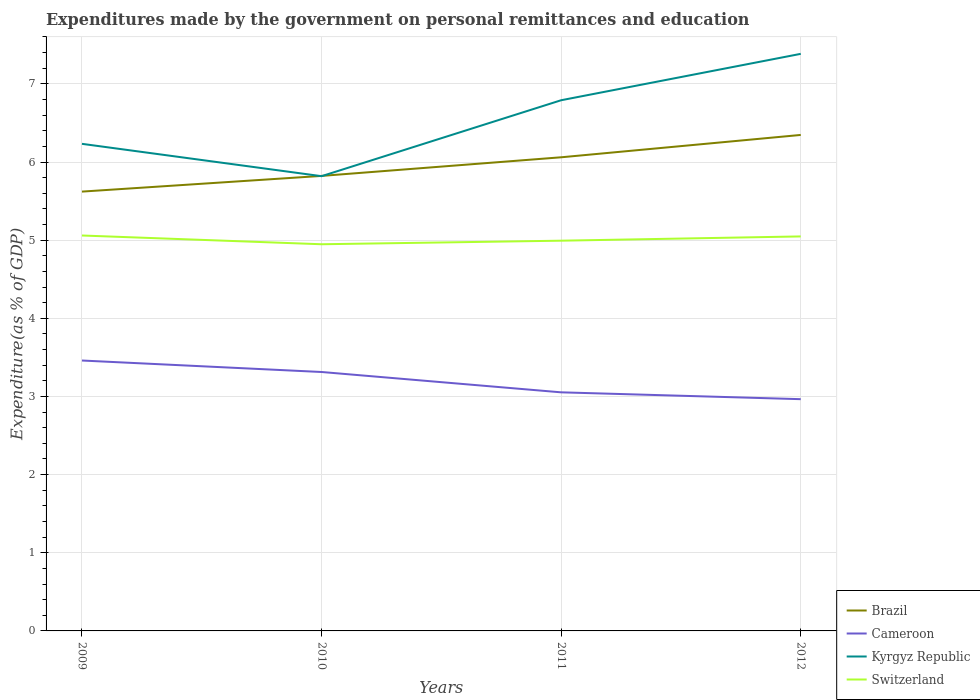Does the line corresponding to Switzerland intersect with the line corresponding to Brazil?
Provide a short and direct response. No. Is the number of lines equal to the number of legend labels?
Your answer should be very brief. Yes. Across all years, what is the maximum expenditures made by the government on personal remittances and education in Kyrgyz Republic?
Provide a succinct answer. 5.82. In which year was the expenditures made by the government on personal remittances and education in Cameroon maximum?
Offer a very short reply. 2012. What is the total expenditures made by the government on personal remittances and education in Cameroon in the graph?
Keep it short and to the point. 0.35. What is the difference between the highest and the second highest expenditures made by the government on personal remittances and education in Switzerland?
Provide a succinct answer. 0.11. What is the difference between the highest and the lowest expenditures made by the government on personal remittances and education in Switzerland?
Your answer should be compact. 2. Is the expenditures made by the government on personal remittances and education in Kyrgyz Republic strictly greater than the expenditures made by the government on personal remittances and education in Cameroon over the years?
Keep it short and to the point. No. How many lines are there?
Your answer should be very brief. 4. How many years are there in the graph?
Ensure brevity in your answer.  4. What is the difference between two consecutive major ticks on the Y-axis?
Your answer should be compact. 1. Does the graph contain grids?
Keep it short and to the point. Yes. What is the title of the graph?
Offer a very short reply. Expenditures made by the government on personal remittances and education. What is the label or title of the X-axis?
Your answer should be compact. Years. What is the label or title of the Y-axis?
Ensure brevity in your answer.  Expenditure(as % of GDP). What is the Expenditure(as % of GDP) of Brazil in 2009?
Make the answer very short. 5.62. What is the Expenditure(as % of GDP) in Cameroon in 2009?
Make the answer very short. 3.46. What is the Expenditure(as % of GDP) of Kyrgyz Republic in 2009?
Your response must be concise. 6.23. What is the Expenditure(as % of GDP) in Switzerland in 2009?
Keep it short and to the point. 5.06. What is the Expenditure(as % of GDP) in Brazil in 2010?
Give a very brief answer. 5.82. What is the Expenditure(as % of GDP) of Cameroon in 2010?
Provide a short and direct response. 3.31. What is the Expenditure(as % of GDP) of Kyrgyz Republic in 2010?
Keep it short and to the point. 5.82. What is the Expenditure(as % of GDP) of Switzerland in 2010?
Ensure brevity in your answer.  4.95. What is the Expenditure(as % of GDP) of Brazil in 2011?
Your response must be concise. 6.06. What is the Expenditure(as % of GDP) in Cameroon in 2011?
Your response must be concise. 3.05. What is the Expenditure(as % of GDP) of Kyrgyz Republic in 2011?
Give a very brief answer. 6.79. What is the Expenditure(as % of GDP) in Switzerland in 2011?
Your answer should be compact. 4.99. What is the Expenditure(as % of GDP) of Brazil in 2012?
Offer a very short reply. 6.35. What is the Expenditure(as % of GDP) in Cameroon in 2012?
Provide a short and direct response. 2.97. What is the Expenditure(as % of GDP) in Kyrgyz Republic in 2012?
Provide a succinct answer. 7.38. What is the Expenditure(as % of GDP) of Switzerland in 2012?
Make the answer very short. 5.05. Across all years, what is the maximum Expenditure(as % of GDP) of Brazil?
Provide a short and direct response. 6.35. Across all years, what is the maximum Expenditure(as % of GDP) of Cameroon?
Offer a very short reply. 3.46. Across all years, what is the maximum Expenditure(as % of GDP) in Kyrgyz Republic?
Provide a succinct answer. 7.38. Across all years, what is the maximum Expenditure(as % of GDP) of Switzerland?
Keep it short and to the point. 5.06. Across all years, what is the minimum Expenditure(as % of GDP) in Brazil?
Your answer should be very brief. 5.62. Across all years, what is the minimum Expenditure(as % of GDP) of Cameroon?
Your response must be concise. 2.97. Across all years, what is the minimum Expenditure(as % of GDP) of Kyrgyz Republic?
Make the answer very short. 5.82. Across all years, what is the minimum Expenditure(as % of GDP) in Switzerland?
Provide a short and direct response. 4.95. What is the total Expenditure(as % of GDP) of Brazil in the graph?
Your answer should be very brief. 23.85. What is the total Expenditure(as % of GDP) of Cameroon in the graph?
Your response must be concise. 12.79. What is the total Expenditure(as % of GDP) of Kyrgyz Republic in the graph?
Offer a very short reply. 26.23. What is the total Expenditure(as % of GDP) of Switzerland in the graph?
Your response must be concise. 20.05. What is the difference between the Expenditure(as % of GDP) in Brazil in 2009 and that in 2010?
Ensure brevity in your answer.  -0.2. What is the difference between the Expenditure(as % of GDP) in Cameroon in 2009 and that in 2010?
Give a very brief answer. 0.15. What is the difference between the Expenditure(as % of GDP) in Kyrgyz Republic in 2009 and that in 2010?
Offer a very short reply. 0.41. What is the difference between the Expenditure(as % of GDP) in Switzerland in 2009 and that in 2010?
Keep it short and to the point. 0.11. What is the difference between the Expenditure(as % of GDP) in Brazil in 2009 and that in 2011?
Provide a succinct answer. -0.44. What is the difference between the Expenditure(as % of GDP) of Cameroon in 2009 and that in 2011?
Ensure brevity in your answer.  0.41. What is the difference between the Expenditure(as % of GDP) in Kyrgyz Republic in 2009 and that in 2011?
Offer a very short reply. -0.56. What is the difference between the Expenditure(as % of GDP) of Switzerland in 2009 and that in 2011?
Keep it short and to the point. 0.07. What is the difference between the Expenditure(as % of GDP) of Brazil in 2009 and that in 2012?
Your answer should be compact. -0.73. What is the difference between the Expenditure(as % of GDP) of Cameroon in 2009 and that in 2012?
Your answer should be compact. 0.49. What is the difference between the Expenditure(as % of GDP) of Kyrgyz Republic in 2009 and that in 2012?
Your response must be concise. -1.15. What is the difference between the Expenditure(as % of GDP) in Switzerland in 2009 and that in 2012?
Your response must be concise. 0.01. What is the difference between the Expenditure(as % of GDP) in Brazil in 2010 and that in 2011?
Give a very brief answer. -0.24. What is the difference between the Expenditure(as % of GDP) of Cameroon in 2010 and that in 2011?
Offer a very short reply. 0.26. What is the difference between the Expenditure(as % of GDP) in Kyrgyz Republic in 2010 and that in 2011?
Your answer should be compact. -0.97. What is the difference between the Expenditure(as % of GDP) in Switzerland in 2010 and that in 2011?
Offer a terse response. -0.05. What is the difference between the Expenditure(as % of GDP) of Brazil in 2010 and that in 2012?
Provide a short and direct response. -0.52. What is the difference between the Expenditure(as % of GDP) of Cameroon in 2010 and that in 2012?
Your response must be concise. 0.35. What is the difference between the Expenditure(as % of GDP) of Kyrgyz Republic in 2010 and that in 2012?
Your answer should be compact. -1.57. What is the difference between the Expenditure(as % of GDP) of Switzerland in 2010 and that in 2012?
Your response must be concise. -0.1. What is the difference between the Expenditure(as % of GDP) in Brazil in 2011 and that in 2012?
Your answer should be very brief. -0.29. What is the difference between the Expenditure(as % of GDP) of Cameroon in 2011 and that in 2012?
Your answer should be very brief. 0.09. What is the difference between the Expenditure(as % of GDP) in Kyrgyz Republic in 2011 and that in 2012?
Your answer should be very brief. -0.59. What is the difference between the Expenditure(as % of GDP) of Switzerland in 2011 and that in 2012?
Provide a succinct answer. -0.05. What is the difference between the Expenditure(as % of GDP) in Brazil in 2009 and the Expenditure(as % of GDP) in Cameroon in 2010?
Keep it short and to the point. 2.31. What is the difference between the Expenditure(as % of GDP) in Brazil in 2009 and the Expenditure(as % of GDP) in Kyrgyz Republic in 2010?
Offer a terse response. -0.2. What is the difference between the Expenditure(as % of GDP) of Brazil in 2009 and the Expenditure(as % of GDP) of Switzerland in 2010?
Your response must be concise. 0.67. What is the difference between the Expenditure(as % of GDP) in Cameroon in 2009 and the Expenditure(as % of GDP) in Kyrgyz Republic in 2010?
Make the answer very short. -2.36. What is the difference between the Expenditure(as % of GDP) in Cameroon in 2009 and the Expenditure(as % of GDP) in Switzerland in 2010?
Provide a short and direct response. -1.49. What is the difference between the Expenditure(as % of GDP) in Kyrgyz Republic in 2009 and the Expenditure(as % of GDP) in Switzerland in 2010?
Make the answer very short. 1.28. What is the difference between the Expenditure(as % of GDP) of Brazil in 2009 and the Expenditure(as % of GDP) of Cameroon in 2011?
Provide a short and direct response. 2.57. What is the difference between the Expenditure(as % of GDP) of Brazil in 2009 and the Expenditure(as % of GDP) of Kyrgyz Republic in 2011?
Your response must be concise. -1.17. What is the difference between the Expenditure(as % of GDP) in Brazil in 2009 and the Expenditure(as % of GDP) in Switzerland in 2011?
Provide a short and direct response. 0.63. What is the difference between the Expenditure(as % of GDP) of Cameroon in 2009 and the Expenditure(as % of GDP) of Kyrgyz Republic in 2011?
Your answer should be compact. -3.33. What is the difference between the Expenditure(as % of GDP) of Cameroon in 2009 and the Expenditure(as % of GDP) of Switzerland in 2011?
Provide a succinct answer. -1.53. What is the difference between the Expenditure(as % of GDP) in Kyrgyz Republic in 2009 and the Expenditure(as % of GDP) in Switzerland in 2011?
Offer a very short reply. 1.24. What is the difference between the Expenditure(as % of GDP) of Brazil in 2009 and the Expenditure(as % of GDP) of Cameroon in 2012?
Your response must be concise. 2.66. What is the difference between the Expenditure(as % of GDP) in Brazil in 2009 and the Expenditure(as % of GDP) in Kyrgyz Republic in 2012?
Provide a succinct answer. -1.76. What is the difference between the Expenditure(as % of GDP) of Brazil in 2009 and the Expenditure(as % of GDP) of Switzerland in 2012?
Keep it short and to the point. 0.57. What is the difference between the Expenditure(as % of GDP) in Cameroon in 2009 and the Expenditure(as % of GDP) in Kyrgyz Republic in 2012?
Keep it short and to the point. -3.92. What is the difference between the Expenditure(as % of GDP) of Cameroon in 2009 and the Expenditure(as % of GDP) of Switzerland in 2012?
Your answer should be compact. -1.59. What is the difference between the Expenditure(as % of GDP) of Kyrgyz Republic in 2009 and the Expenditure(as % of GDP) of Switzerland in 2012?
Your response must be concise. 1.18. What is the difference between the Expenditure(as % of GDP) in Brazil in 2010 and the Expenditure(as % of GDP) in Cameroon in 2011?
Make the answer very short. 2.77. What is the difference between the Expenditure(as % of GDP) in Brazil in 2010 and the Expenditure(as % of GDP) in Kyrgyz Republic in 2011?
Provide a short and direct response. -0.97. What is the difference between the Expenditure(as % of GDP) in Brazil in 2010 and the Expenditure(as % of GDP) in Switzerland in 2011?
Your answer should be very brief. 0.83. What is the difference between the Expenditure(as % of GDP) of Cameroon in 2010 and the Expenditure(as % of GDP) of Kyrgyz Republic in 2011?
Your response must be concise. -3.48. What is the difference between the Expenditure(as % of GDP) of Cameroon in 2010 and the Expenditure(as % of GDP) of Switzerland in 2011?
Your response must be concise. -1.68. What is the difference between the Expenditure(as % of GDP) of Kyrgyz Republic in 2010 and the Expenditure(as % of GDP) of Switzerland in 2011?
Keep it short and to the point. 0.83. What is the difference between the Expenditure(as % of GDP) in Brazil in 2010 and the Expenditure(as % of GDP) in Cameroon in 2012?
Offer a terse response. 2.86. What is the difference between the Expenditure(as % of GDP) in Brazil in 2010 and the Expenditure(as % of GDP) in Kyrgyz Republic in 2012?
Provide a short and direct response. -1.56. What is the difference between the Expenditure(as % of GDP) in Brazil in 2010 and the Expenditure(as % of GDP) in Switzerland in 2012?
Ensure brevity in your answer.  0.77. What is the difference between the Expenditure(as % of GDP) in Cameroon in 2010 and the Expenditure(as % of GDP) in Kyrgyz Republic in 2012?
Provide a succinct answer. -4.07. What is the difference between the Expenditure(as % of GDP) of Cameroon in 2010 and the Expenditure(as % of GDP) of Switzerland in 2012?
Offer a very short reply. -1.73. What is the difference between the Expenditure(as % of GDP) in Kyrgyz Republic in 2010 and the Expenditure(as % of GDP) in Switzerland in 2012?
Your response must be concise. 0.77. What is the difference between the Expenditure(as % of GDP) of Brazil in 2011 and the Expenditure(as % of GDP) of Cameroon in 2012?
Keep it short and to the point. 3.1. What is the difference between the Expenditure(as % of GDP) in Brazil in 2011 and the Expenditure(as % of GDP) in Kyrgyz Republic in 2012?
Give a very brief answer. -1.32. What is the difference between the Expenditure(as % of GDP) of Brazil in 2011 and the Expenditure(as % of GDP) of Switzerland in 2012?
Give a very brief answer. 1.01. What is the difference between the Expenditure(as % of GDP) in Cameroon in 2011 and the Expenditure(as % of GDP) in Kyrgyz Republic in 2012?
Give a very brief answer. -4.33. What is the difference between the Expenditure(as % of GDP) of Cameroon in 2011 and the Expenditure(as % of GDP) of Switzerland in 2012?
Your answer should be compact. -2. What is the difference between the Expenditure(as % of GDP) in Kyrgyz Republic in 2011 and the Expenditure(as % of GDP) in Switzerland in 2012?
Give a very brief answer. 1.74. What is the average Expenditure(as % of GDP) of Brazil per year?
Keep it short and to the point. 5.96. What is the average Expenditure(as % of GDP) of Cameroon per year?
Make the answer very short. 3.2. What is the average Expenditure(as % of GDP) of Kyrgyz Republic per year?
Your answer should be very brief. 6.56. What is the average Expenditure(as % of GDP) in Switzerland per year?
Provide a short and direct response. 5.01. In the year 2009, what is the difference between the Expenditure(as % of GDP) of Brazil and Expenditure(as % of GDP) of Cameroon?
Provide a succinct answer. 2.16. In the year 2009, what is the difference between the Expenditure(as % of GDP) in Brazil and Expenditure(as % of GDP) in Kyrgyz Republic?
Offer a very short reply. -0.61. In the year 2009, what is the difference between the Expenditure(as % of GDP) of Brazil and Expenditure(as % of GDP) of Switzerland?
Offer a very short reply. 0.56. In the year 2009, what is the difference between the Expenditure(as % of GDP) of Cameroon and Expenditure(as % of GDP) of Kyrgyz Republic?
Your response must be concise. -2.77. In the year 2009, what is the difference between the Expenditure(as % of GDP) in Cameroon and Expenditure(as % of GDP) in Switzerland?
Provide a short and direct response. -1.6. In the year 2009, what is the difference between the Expenditure(as % of GDP) in Kyrgyz Republic and Expenditure(as % of GDP) in Switzerland?
Provide a succinct answer. 1.17. In the year 2010, what is the difference between the Expenditure(as % of GDP) of Brazil and Expenditure(as % of GDP) of Cameroon?
Your answer should be compact. 2.51. In the year 2010, what is the difference between the Expenditure(as % of GDP) of Brazil and Expenditure(as % of GDP) of Kyrgyz Republic?
Make the answer very short. 0. In the year 2010, what is the difference between the Expenditure(as % of GDP) of Brazil and Expenditure(as % of GDP) of Switzerland?
Provide a succinct answer. 0.87. In the year 2010, what is the difference between the Expenditure(as % of GDP) of Cameroon and Expenditure(as % of GDP) of Kyrgyz Republic?
Provide a short and direct response. -2.51. In the year 2010, what is the difference between the Expenditure(as % of GDP) of Cameroon and Expenditure(as % of GDP) of Switzerland?
Make the answer very short. -1.63. In the year 2010, what is the difference between the Expenditure(as % of GDP) of Kyrgyz Republic and Expenditure(as % of GDP) of Switzerland?
Keep it short and to the point. 0.87. In the year 2011, what is the difference between the Expenditure(as % of GDP) of Brazil and Expenditure(as % of GDP) of Cameroon?
Keep it short and to the point. 3.01. In the year 2011, what is the difference between the Expenditure(as % of GDP) in Brazil and Expenditure(as % of GDP) in Kyrgyz Republic?
Offer a very short reply. -0.73. In the year 2011, what is the difference between the Expenditure(as % of GDP) of Brazil and Expenditure(as % of GDP) of Switzerland?
Make the answer very short. 1.07. In the year 2011, what is the difference between the Expenditure(as % of GDP) in Cameroon and Expenditure(as % of GDP) in Kyrgyz Republic?
Your answer should be very brief. -3.74. In the year 2011, what is the difference between the Expenditure(as % of GDP) in Cameroon and Expenditure(as % of GDP) in Switzerland?
Ensure brevity in your answer.  -1.94. In the year 2011, what is the difference between the Expenditure(as % of GDP) in Kyrgyz Republic and Expenditure(as % of GDP) in Switzerland?
Your answer should be very brief. 1.8. In the year 2012, what is the difference between the Expenditure(as % of GDP) of Brazil and Expenditure(as % of GDP) of Cameroon?
Your answer should be compact. 3.38. In the year 2012, what is the difference between the Expenditure(as % of GDP) in Brazil and Expenditure(as % of GDP) in Kyrgyz Republic?
Ensure brevity in your answer.  -1.04. In the year 2012, what is the difference between the Expenditure(as % of GDP) in Brazil and Expenditure(as % of GDP) in Switzerland?
Provide a short and direct response. 1.3. In the year 2012, what is the difference between the Expenditure(as % of GDP) of Cameroon and Expenditure(as % of GDP) of Kyrgyz Republic?
Your answer should be very brief. -4.42. In the year 2012, what is the difference between the Expenditure(as % of GDP) in Cameroon and Expenditure(as % of GDP) in Switzerland?
Ensure brevity in your answer.  -2.08. In the year 2012, what is the difference between the Expenditure(as % of GDP) of Kyrgyz Republic and Expenditure(as % of GDP) of Switzerland?
Make the answer very short. 2.34. What is the ratio of the Expenditure(as % of GDP) of Brazil in 2009 to that in 2010?
Ensure brevity in your answer.  0.97. What is the ratio of the Expenditure(as % of GDP) of Cameroon in 2009 to that in 2010?
Your response must be concise. 1.04. What is the ratio of the Expenditure(as % of GDP) in Kyrgyz Republic in 2009 to that in 2010?
Your response must be concise. 1.07. What is the ratio of the Expenditure(as % of GDP) of Switzerland in 2009 to that in 2010?
Make the answer very short. 1.02. What is the ratio of the Expenditure(as % of GDP) in Brazil in 2009 to that in 2011?
Give a very brief answer. 0.93. What is the ratio of the Expenditure(as % of GDP) in Cameroon in 2009 to that in 2011?
Your answer should be compact. 1.13. What is the ratio of the Expenditure(as % of GDP) in Kyrgyz Republic in 2009 to that in 2011?
Provide a short and direct response. 0.92. What is the ratio of the Expenditure(as % of GDP) of Switzerland in 2009 to that in 2011?
Ensure brevity in your answer.  1.01. What is the ratio of the Expenditure(as % of GDP) of Brazil in 2009 to that in 2012?
Provide a short and direct response. 0.89. What is the ratio of the Expenditure(as % of GDP) of Cameroon in 2009 to that in 2012?
Offer a terse response. 1.17. What is the ratio of the Expenditure(as % of GDP) in Kyrgyz Republic in 2009 to that in 2012?
Your answer should be compact. 0.84. What is the ratio of the Expenditure(as % of GDP) in Brazil in 2010 to that in 2011?
Offer a very short reply. 0.96. What is the ratio of the Expenditure(as % of GDP) in Cameroon in 2010 to that in 2011?
Your answer should be very brief. 1.09. What is the ratio of the Expenditure(as % of GDP) of Kyrgyz Republic in 2010 to that in 2011?
Your answer should be very brief. 0.86. What is the ratio of the Expenditure(as % of GDP) of Switzerland in 2010 to that in 2011?
Make the answer very short. 0.99. What is the ratio of the Expenditure(as % of GDP) in Brazil in 2010 to that in 2012?
Give a very brief answer. 0.92. What is the ratio of the Expenditure(as % of GDP) in Cameroon in 2010 to that in 2012?
Give a very brief answer. 1.12. What is the ratio of the Expenditure(as % of GDP) in Kyrgyz Republic in 2010 to that in 2012?
Give a very brief answer. 0.79. What is the ratio of the Expenditure(as % of GDP) in Switzerland in 2010 to that in 2012?
Provide a short and direct response. 0.98. What is the ratio of the Expenditure(as % of GDP) in Brazil in 2011 to that in 2012?
Ensure brevity in your answer.  0.95. What is the ratio of the Expenditure(as % of GDP) of Cameroon in 2011 to that in 2012?
Ensure brevity in your answer.  1.03. What is the ratio of the Expenditure(as % of GDP) in Kyrgyz Republic in 2011 to that in 2012?
Your answer should be compact. 0.92. What is the difference between the highest and the second highest Expenditure(as % of GDP) of Brazil?
Ensure brevity in your answer.  0.29. What is the difference between the highest and the second highest Expenditure(as % of GDP) in Cameroon?
Ensure brevity in your answer.  0.15. What is the difference between the highest and the second highest Expenditure(as % of GDP) of Kyrgyz Republic?
Your answer should be very brief. 0.59. What is the difference between the highest and the second highest Expenditure(as % of GDP) of Switzerland?
Keep it short and to the point. 0.01. What is the difference between the highest and the lowest Expenditure(as % of GDP) of Brazil?
Provide a short and direct response. 0.73. What is the difference between the highest and the lowest Expenditure(as % of GDP) of Cameroon?
Offer a very short reply. 0.49. What is the difference between the highest and the lowest Expenditure(as % of GDP) in Kyrgyz Republic?
Your response must be concise. 1.57. What is the difference between the highest and the lowest Expenditure(as % of GDP) in Switzerland?
Provide a short and direct response. 0.11. 